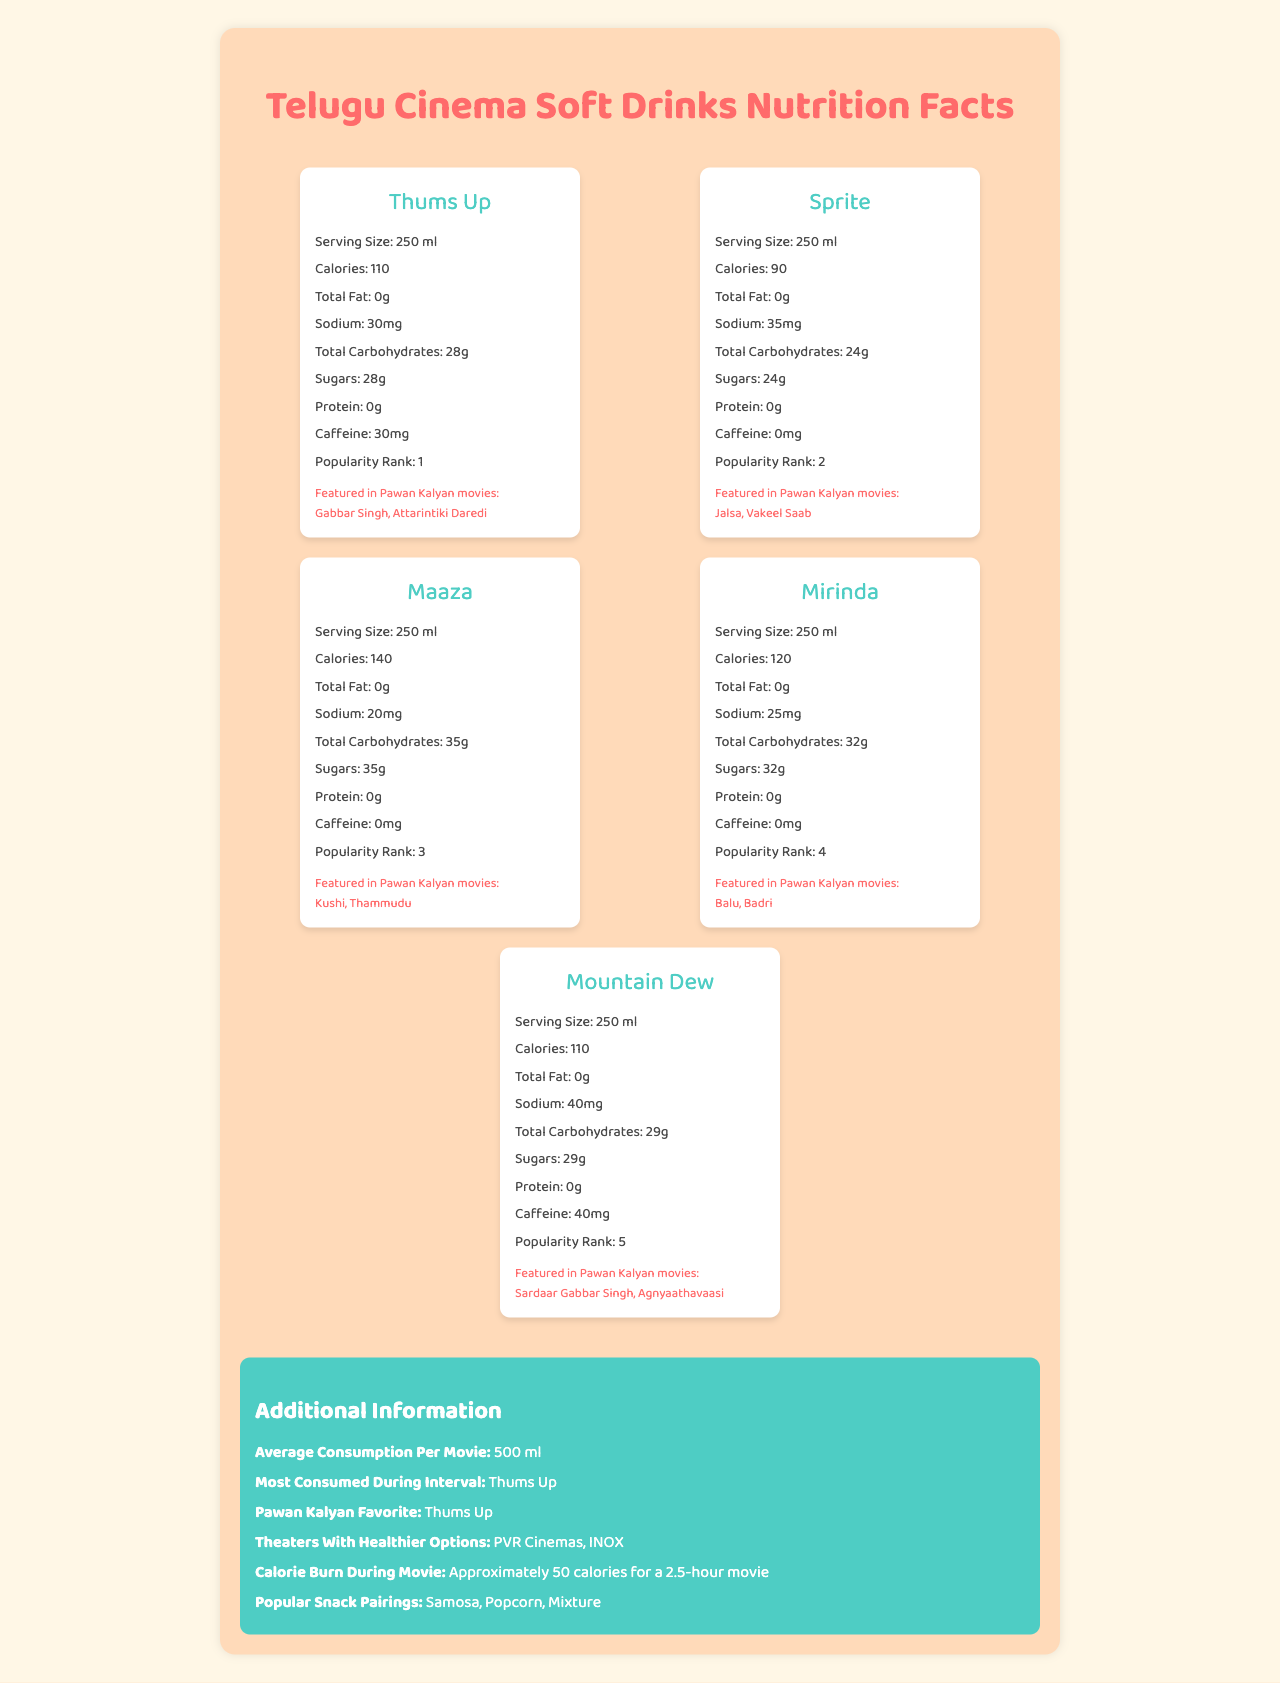what is the serving size for Sprite? The document lists "Sprite" with a serving size of "250 ml".
Answer: 250 ml which drink has the highest amount of sugars? A. Thums Up B. Sprite C. Maaza D. Mirinda E. Mountain Dew Maaza contains 35g of sugars, which is the highest among the listed drinks.
Answer: C. Maaza is Mirinda caffeine-free? According to the document, Mirinda contains 0 mg of caffeine.
Answer: Yes which drinks are featured in Pawan Kalyan's movie "Gabbar Singh"? Thums Up is the only drink listed as featured in "Gabbar Singh".
Answer: Thums Up what is Pawan Kalyan's favorite soft drink? The additional information section mentions that Pawan Kalyan's favorite soft drink is Thums Up.
Answer: Thums Up which drink has the lowest sodium content? Maaza has 20 mg of sodium, which is the lowest among the listed drinks.
Answer: Maaza which soft drink appears in "Jalsa"? A. Thums Up B. Sprite C. Maaza D. Mirinda E. Mountain Dew Sprite is listed as featured in "Jalsa" among Pawan Kalyan movies.
Answer: B. Sprite what is the average consumption of soft drinks per movie? The additional information section states that the average consumption per movie is 500 ml.
Answer: 500 ml how many Pawan Kalyan movies feature Maaza? Maaza is featured in "Kushi" and "Thammudu".
Answer: Two what is the total carbohydrate content in Mountain Dew? The document states that Mountain Dew contains 29g of total carbohydrates.
Answer: 29 grams can you determine which snack is the healthiest option to pair with soft drinks? The document mentions popular snack pairings but does not provide nutritional information to determine the healthiest option.
Answer: Not enough information what is the main idea of the document? The main idea of the document is to present the nutritional content of various soft drinks enjoyed in Telugu cinemas, their occurrence in Pawan Kalyan films, and other related facts such as average consumption per movie and popular snack pairings.
Answer: The document provides comparative nutrition facts for popular soft drinks consumed in Telugu cinema theaters, including their appearance in Pawan Kalyan movies, and additional consumption information. 